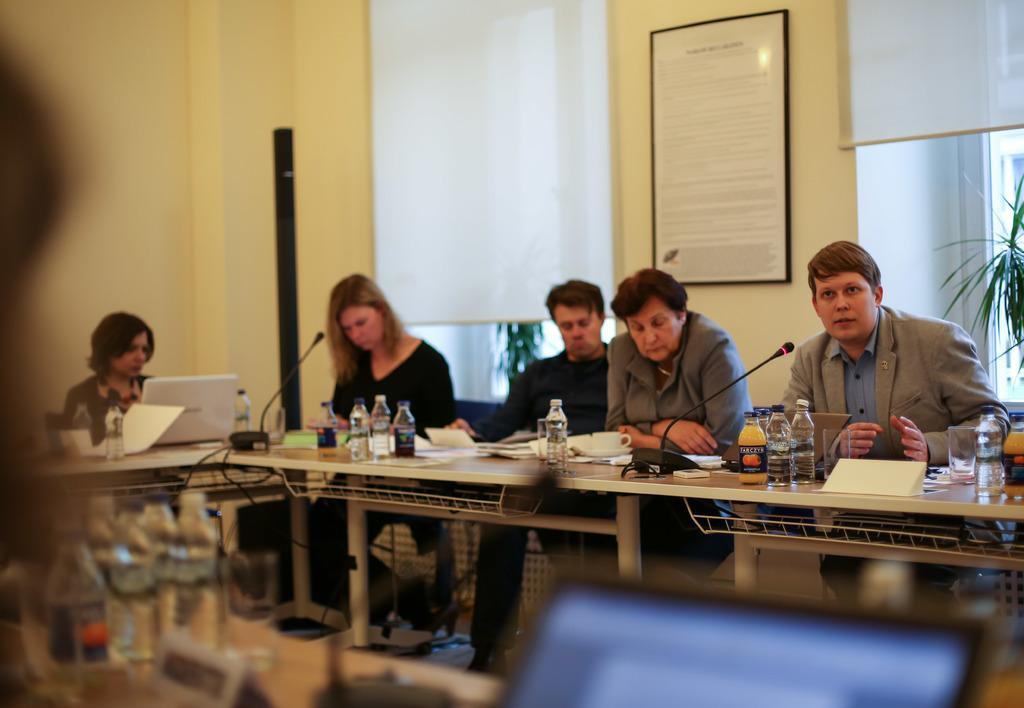What are the persons in the image doing? The persons in the image are sitting on chairs. What is on the table in the image? There is a microphone, bottles, a laptop, a cup, and a paper on the table. What is the purpose of the microphone on the table? The microphone on the table is likely used for amplifying sound or recording audio. What can be seen in the background of the image? There is a wall, a frame, and a plant visible in the background. How many oranges are on the table in the image? There are no oranges present on the table in the image. What fact can be learned about the street from the image? The image does not provide any information about a street, so no fact can be learned about it from the image. 